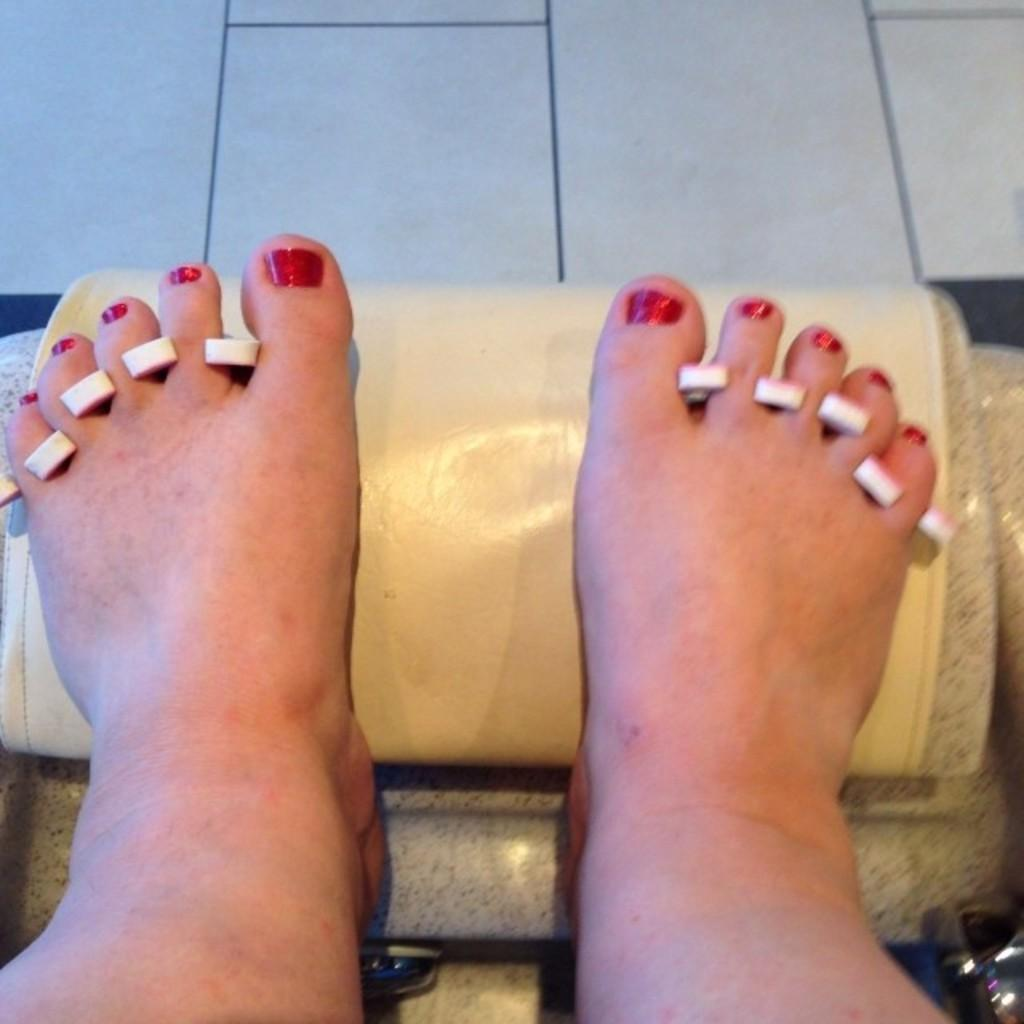What is the main subject of the image? The main subject of the image is the legs of a person. What is the person's legs resting on? The legs are on an object. Can you describe anything visible between the fingers in the image? There are white color things visible between the fingers. How many geese are visible in the image? There are no geese present in the image. What type of collar is the person wearing in the image? There is no collar visible in the image, as only the person's legs are shown. 